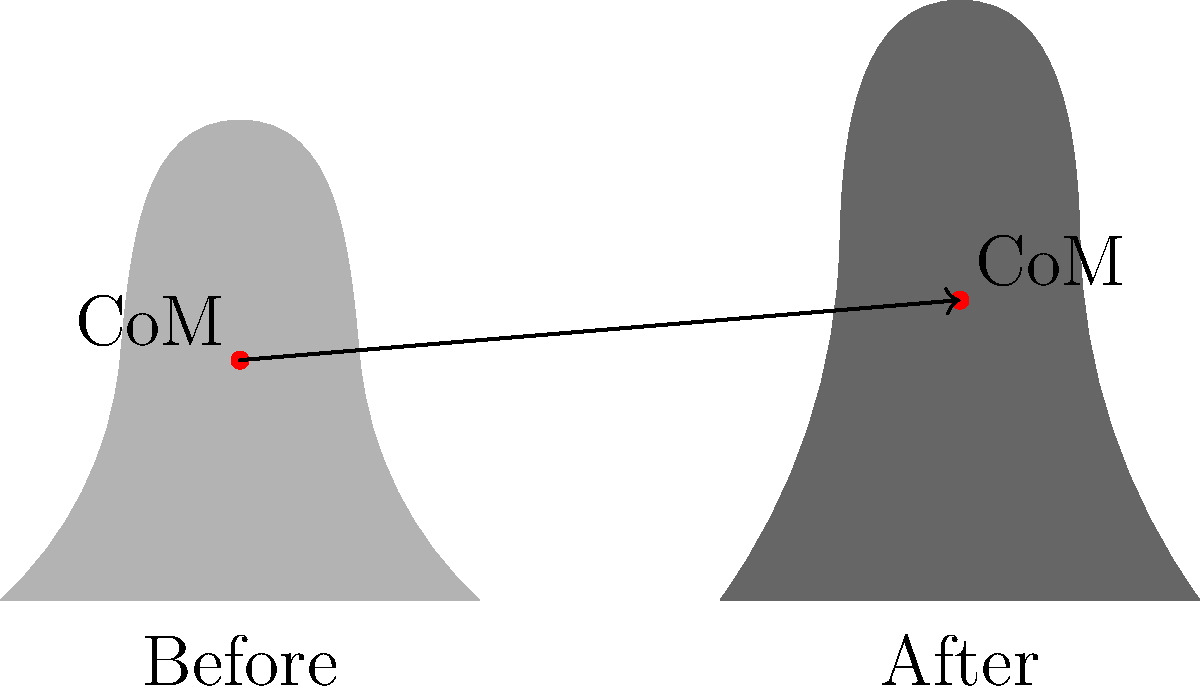In a quick-change costume illusion, a magician's silhouette changes as shown in the figure. If the magician's mass remains constant, how does the vertical shift in the center of mass (CoM) contribute to the illusion's effectiveness? Consider the implications for the detective novel's plot involving a shape-shifting suspect. To understand the role of the center of mass shift in this illusion:

1. Observe the before and after silhouettes:
   - Before: A more compact figure
   - After: A taller, more elongated figure

2. Note the center of mass (CoM) positions:
   - Before: Lower, approximately at the middle of the torso
   - After: Higher, shifted upwards

3. Calculate the vertical shift:
   The CoM has moved upward by about 0.5 units (from y=2 to y=2.5)

4. Biomechanical implications:
   - A higher CoM suggests a redistribution of mass upwards
   - This could be achieved by extending limbs or adding volume to upper body

5. Illusion effectiveness:
   - The vertical CoM shift creates a dramatic change in perceived height and body shape
   - It suggests a transformation from a shorter, stockier figure to a taller, leaner one

6. Plot implications:
   - A shape-shifting suspect could use this technique to alter their apparent physique quickly
   - The detective might look for discrepancies in witness descriptions or surveillance footage
   - The rate of CoM shift could indicate the speed and sophistication of the transformation

7. Mathematical representation:
   The vertical CoM shift (Δy) can be expressed as:
   $$\Delta y = y_{after} - y_{before} = 2.5 - 2 = 0.5$$

8. Energy consideration:
   The change in potential energy (ΔPE) due to CoM shift:
   $$\Delta PE = mg\Delta y$$
   where m is the magician's mass and g is the acceleration due to gravity

This vertical shift in CoM contributes significantly to the illusion's effectiveness by creating a noticeable change in the perceived height and body shape of the performer, which could be a crucial element in a detective novel's plot involving a deceptive, shape-shifting character.
Answer: Upward CoM shift creates illusion of height increase and body reshaping, enhancing transformation believability. 